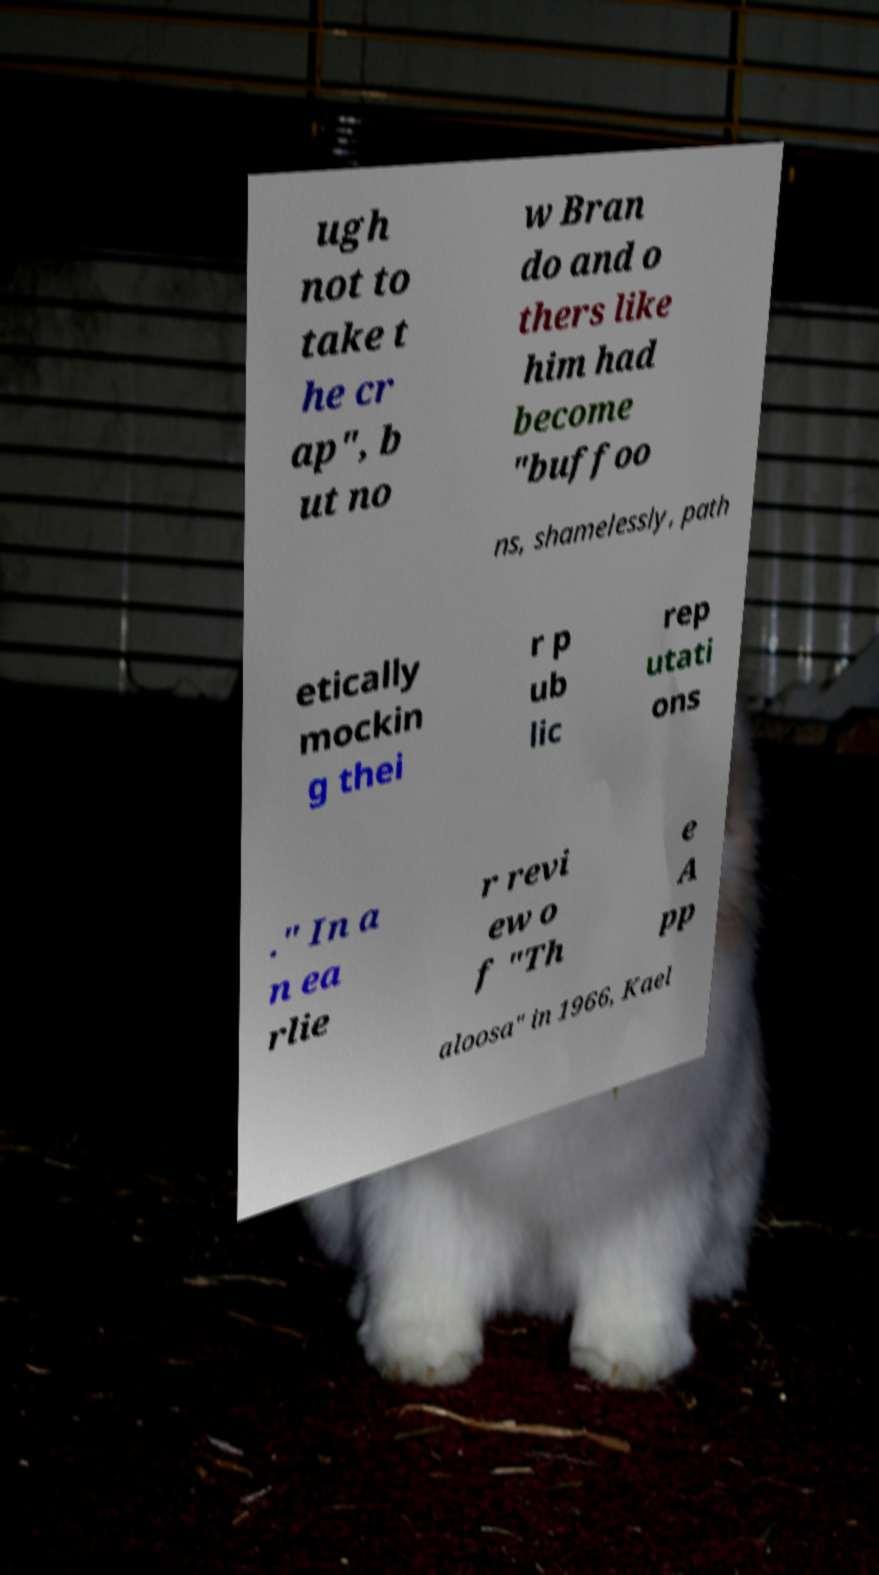Could you extract and type out the text from this image? ugh not to take t he cr ap", b ut no w Bran do and o thers like him had become "buffoo ns, shamelessly, path etically mockin g thei r p ub lic rep utati ons ." In a n ea rlie r revi ew o f "Th e A pp aloosa" in 1966, Kael 